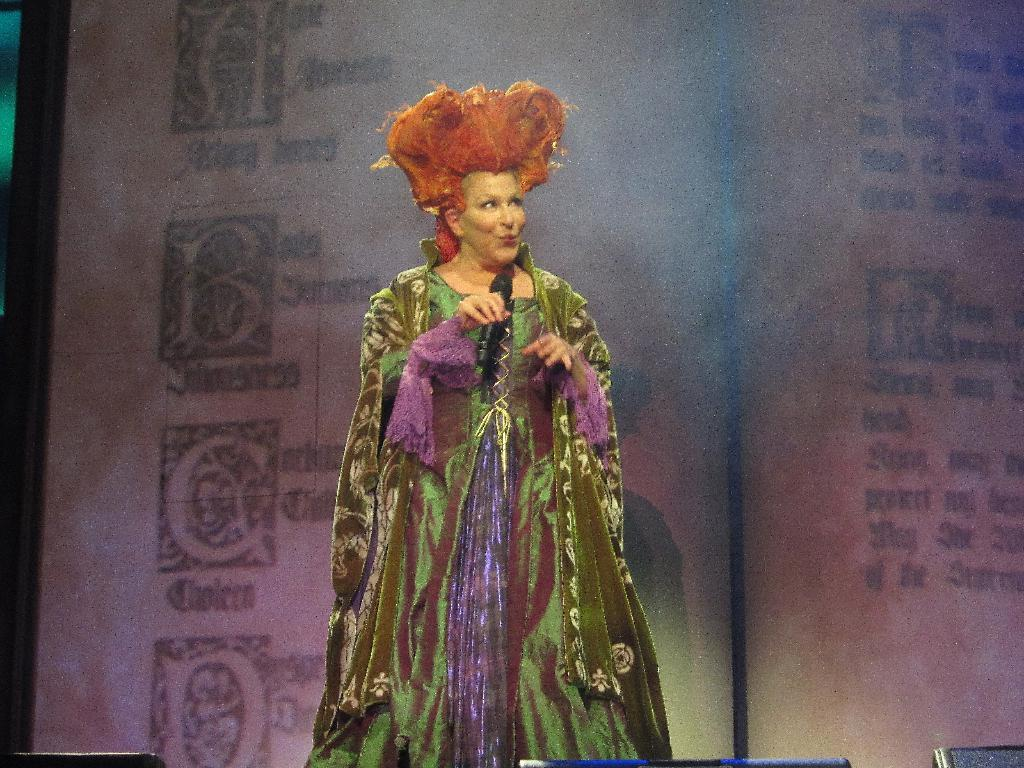What is the person in the image doing? The person is standing and holding a mic. What object is in front of the person? There is a black color object in front of the person. What can be seen at the back of the person? There is a screen with text and images at the back of the person. Can you see a goat in the image? No, there is no goat present in the image. What role does the mother play in the image? There is no mention of a mother in the image or the provided facts. 